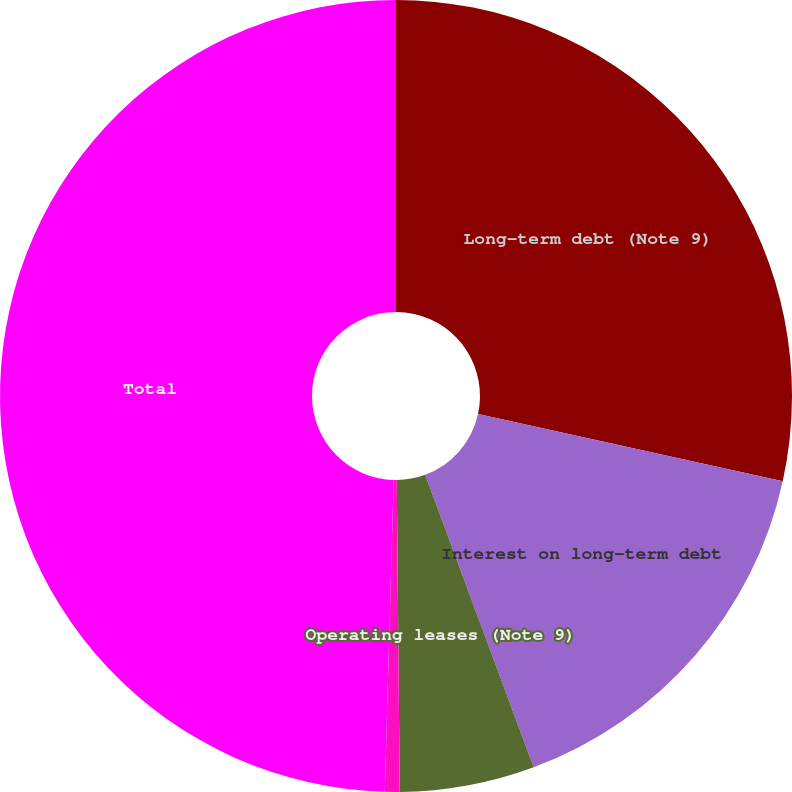Convert chart to OTSL. <chart><loc_0><loc_0><loc_500><loc_500><pie_chart><fcel>Long-term debt (Note 9)<fcel>Interest on long-term debt<fcel>Operating leases (Note 9)<fcel>Retirement benefits (Note 10)<fcel>Total<nl><fcel>28.45%<fcel>15.9%<fcel>5.5%<fcel>0.6%<fcel>49.55%<nl></chart> 